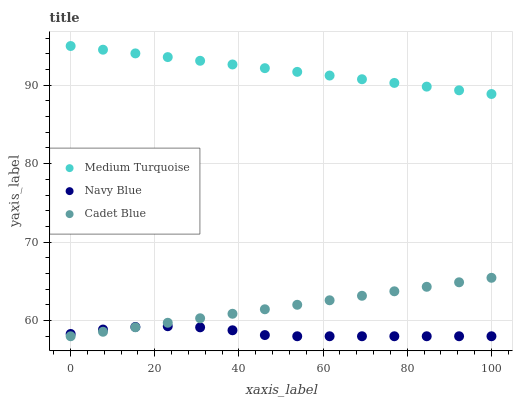Does Navy Blue have the minimum area under the curve?
Answer yes or no. Yes. Does Medium Turquoise have the maximum area under the curve?
Answer yes or no. Yes. Does Cadet Blue have the minimum area under the curve?
Answer yes or no. No. Does Cadet Blue have the maximum area under the curve?
Answer yes or no. No. Is Cadet Blue the smoothest?
Answer yes or no. Yes. Is Navy Blue the roughest?
Answer yes or no. Yes. Is Medium Turquoise the smoothest?
Answer yes or no. No. Is Medium Turquoise the roughest?
Answer yes or no. No. Does Navy Blue have the lowest value?
Answer yes or no. Yes. Does Medium Turquoise have the lowest value?
Answer yes or no. No. Does Medium Turquoise have the highest value?
Answer yes or no. Yes. Does Cadet Blue have the highest value?
Answer yes or no. No. Is Cadet Blue less than Medium Turquoise?
Answer yes or no. Yes. Is Medium Turquoise greater than Navy Blue?
Answer yes or no. Yes. Does Navy Blue intersect Cadet Blue?
Answer yes or no. Yes. Is Navy Blue less than Cadet Blue?
Answer yes or no. No. Is Navy Blue greater than Cadet Blue?
Answer yes or no. No. Does Cadet Blue intersect Medium Turquoise?
Answer yes or no. No. 